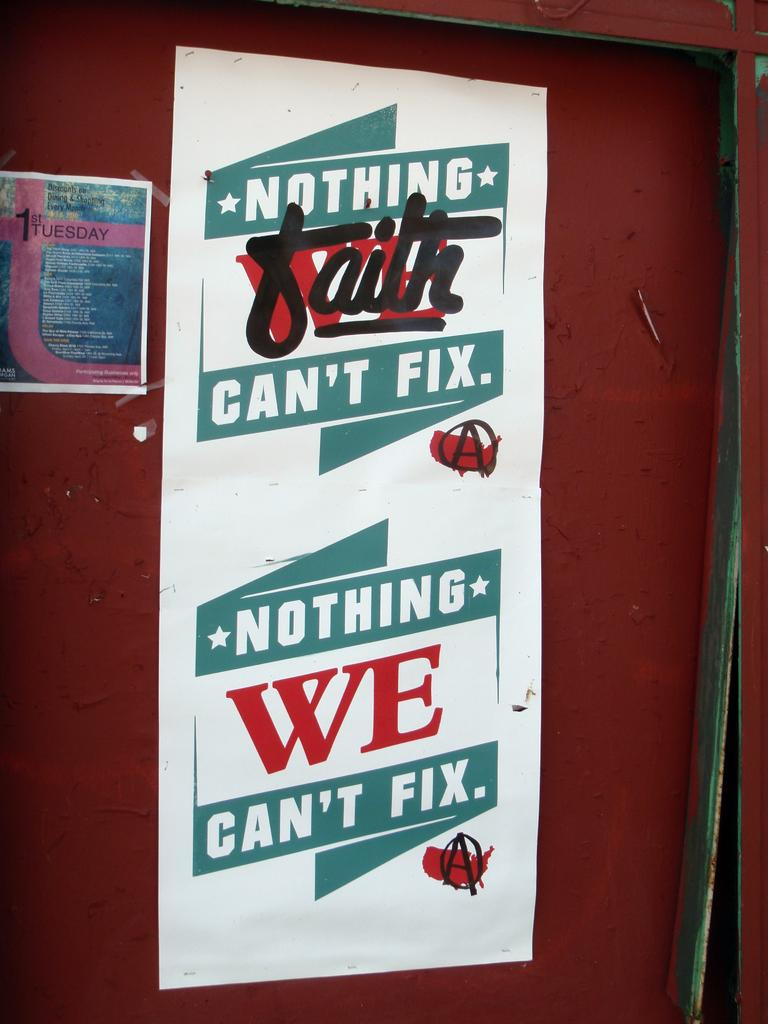Provide a one-sentence caption for the provided image. A poster on a red door reads Nothing Faith Can't Fix, Nothing We Can't Fix. 